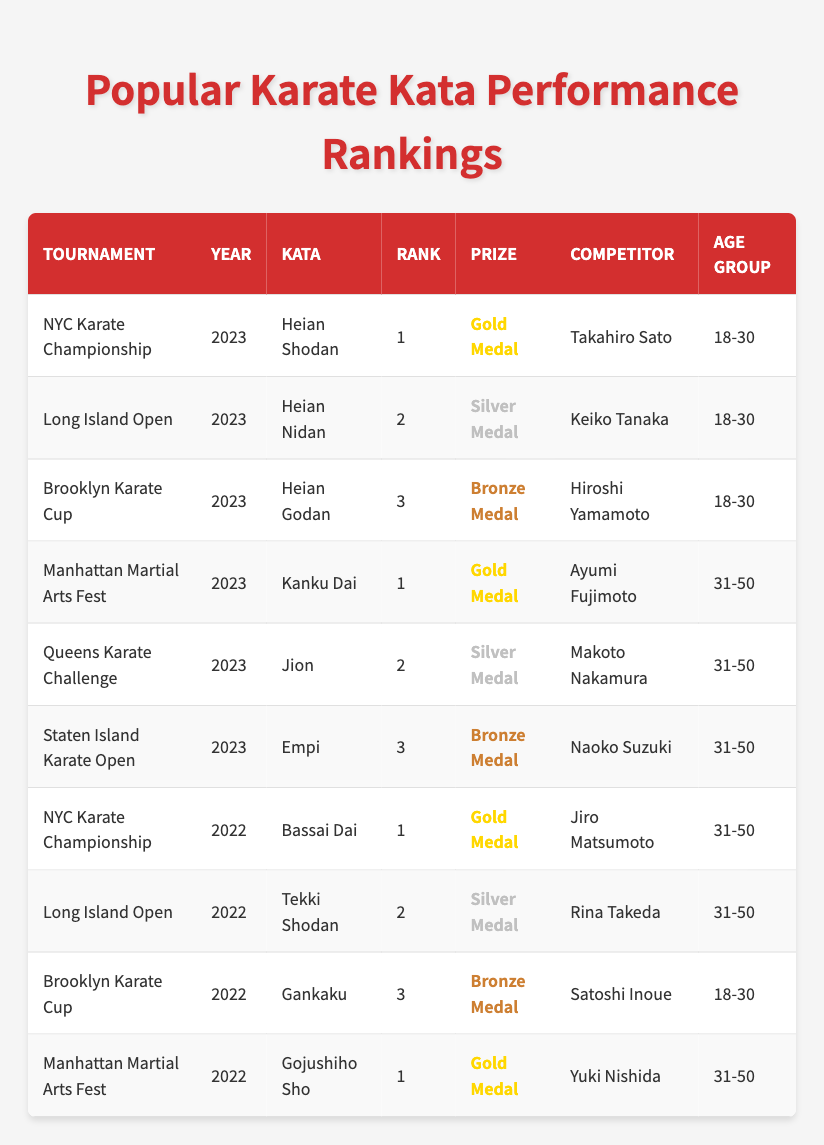What kata did Takahiro Sato perform to win the Gold Medal? According to the table, Takahiro Sato is listed as the competitor who won the Gold Medal in the NYC Karate Championship for the kata "Heian Shodan."
Answer: Heian Shodan Which competitor won the Silver Medal in the 2023 Long Island Open? The table specifies that Keiko Tanaka received the Silver Medal for the kata "Heian Nidan" during the 2023 Long Island Open.
Answer: Keiko Tanaka How many different tournaments are represented in the table? By counting the unique tournament names in the table, we can see that there are five tournaments: NYC Karate Championship, Long Island Open, Brooklyn Karate Cup, Manhattan Martial Arts Fest, and Queens Karate Challenge, plus Staten Island Karate Open and those in 2022. The total is seven distinct tournaments.
Answer: 7 Who won the Gold Medal for the kata "Kanku Dai"? The table shows that Ayumi Fujimoto won the Gold Medal in 2023 for the kata "Kanku Dai" during the Manhattan Martial Arts Fest.
Answer: Ayumi Fujimoto In which year did Jiro Matsumoto win a Gold Medal, and for which kata? The table indicates that Jiro Matsumoto won a Gold Medal in 2022 for the kata "Bassai Dai" at the NYC Karate Championship.
Answer: 2022, Bassai Dai What age group did most competitors belong to in the 2023 tournaments? Analyzing the age groups in the 2023 portion of the table, we can observe that both kata performed by competitors aged 18-30 and those aged 31-50 were represented. However, there are more competitors in the 18-30 age group (3 performances) compared to 31-50 age group (3 performances). Thus, the counts are even.
Answer: Both age groups had equal representation Was there a competitor who won a Gold Medal in both 2022 and 2023? A review of the table confirms that both Ayumi Fujimoto (2023) and Jiro Matsumoto (2022) have individual Gold Medal wins, but each won it in different years and for different katas. Thus, no competitor won a Gold Medal in both years.
Answer: No What is the average rank of all competitors in the 2022 events? The ranks for competitors in 2022 are 1 (Jiro Matsumoto), 2 (Rina Takeda), 3 (Satoshi Inoue), and 1 (Yuki Nishida). The sum of these ranks is 1 + 2 + 3 + 1 = 7. Since there are four competitors, the average rank is 7 / 4 = 1.75.
Answer: 1.75 Which competitor had the best rank in the 2022 Long Island Open? From the table, Rina Takeda is listed as the competitor who received the Silver Medal, which is ranked 2. The highest rank in that tournament was held by the other competitors.
Answer: Rina Takeda (however, for rank 2 in prize) What kata was performed by the oldest competitor group that received a medal? The table shows that Naoko Suzuki, who belongs to the age group 31-50, performed "Empi" and ranked 3rd (Bronze Medal) at the Staten Island Karate Open in 2023.
Answer: Empi How many competitors ranked 1st in 2023? In 2023, the table lists two competitors who achieved a 1st place rank: Takahiro Sato (Heian Shodan) and Ayumi Fujimoto (Kanku Dai). Therefore, there are two competitors.
Answer: 2 